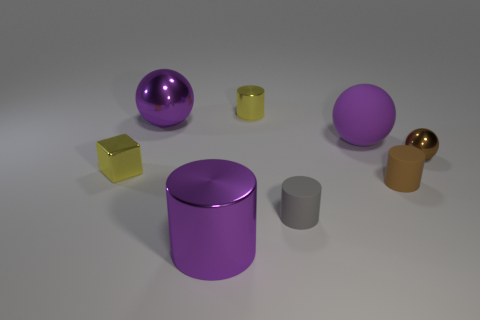Is there a yellow block that has the same size as the yellow cylinder?
Provide a short and direct response. Yes. There is a brown cylinder that is the same size as the metallic block; what is its material?
Your response must be concise. Rubber. What is the size of the shiny ball that is in front of the big purple metal thing that is behind the big matte ball?
Ensure brevity in your answer.  Small. There is a matte ball that is right of the purple metallic cylinder; is it the same size as the gray rubber object?
Keep it short and to the point. No. Is the number of big purple cylinders that are behind the small shiny cube greater than the number of tiny brown matte cylinders that are behind the brown metal ball?
Keep it short and to the point. No. What shape is the tiny shiny thing that is both behind the yellow block and to the left of the purple rubber ball?
Give a very brief answer. Cylinder. The large purple object that is to the right of the yellow cylinder has what shape?
Make the answer very short. Sphere. There is a shiny ball right of the purple metallic thing that is on the right side of the large purple ball that is left of the big purple matte sphere; what is its size?
Ensure brevity in your answer.  Small. Do the gray rubber thing and the tiny brown shiny object have the same shape?
Your answer should be compact. No. There is a object that is both on the right side of the rubber ball and on the left side of the brown shiny thing; what size is it?
Offer a terse response. Small. 